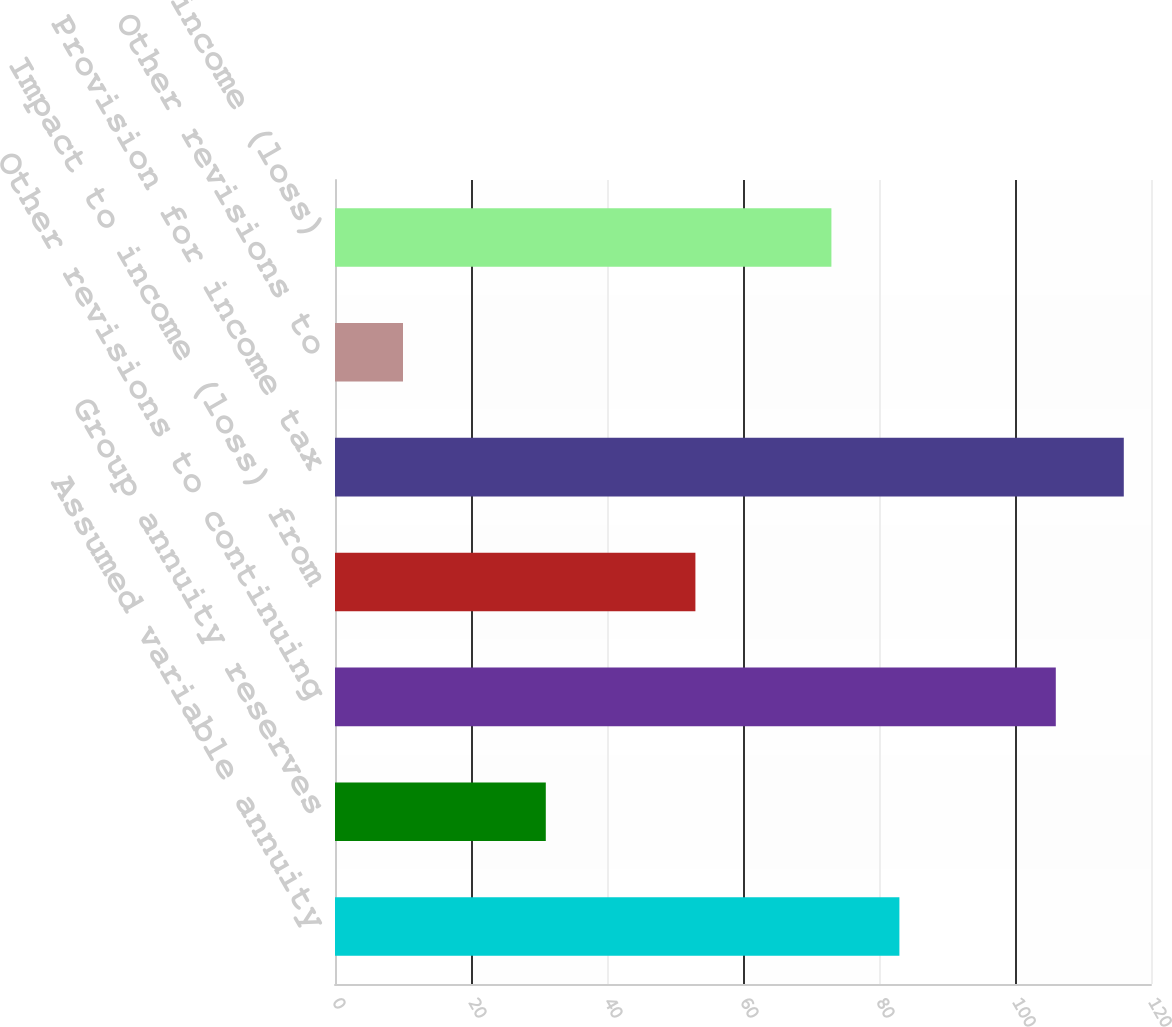Convert chart to OTSL. <chart><loc_0><loc_0><loc_500><loc_500><bar_chart><fcel>Assumed variable annuity<fcel>Group annuity reserves<fcel>Other revisions to continuing<fcel>Impact to income (loss) from<fcel>Provision for income tax<fcel>Other revisions to<fcel>Impact to net income (loss)<nl><fcel>83<fcel>31<fcel>106<fcel>53<fcel>116<fcel>10<fcel>73<nl></chart> 